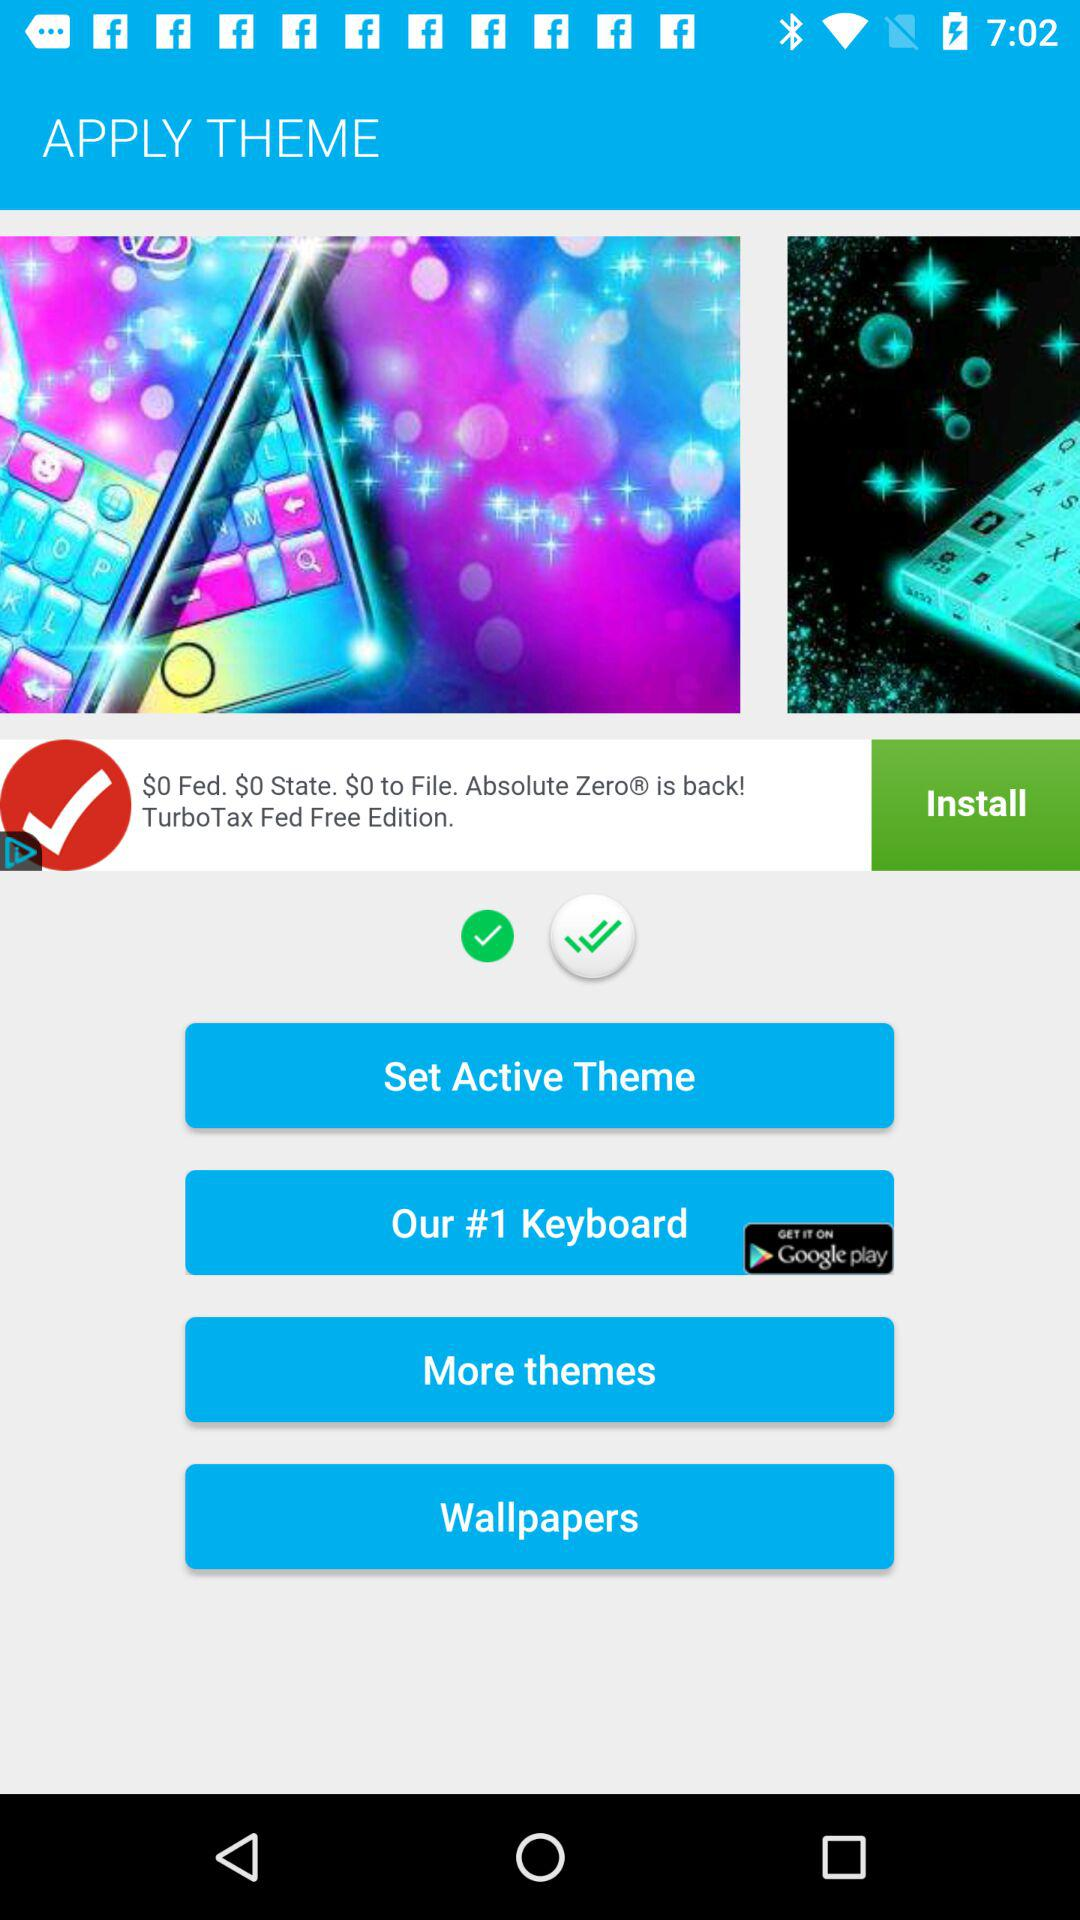How many check marks are there in the bottom of the screen?
Answer the question using a single word or phrase. 2 